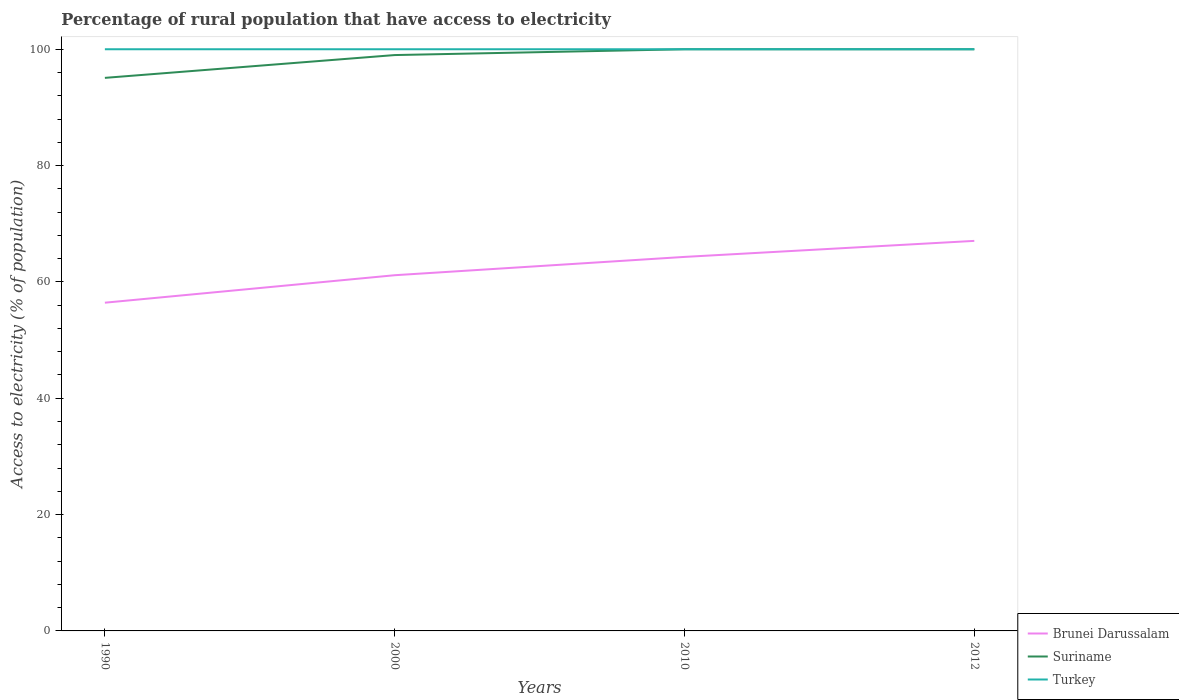Is the number of lines equal to the number of legend labels?
Provide a succinct answer. Yes. Across all years, what is the maximum percentage of rural population that have access to electricity in Turkey?
Ensure brevity in your answer.  100. In which year was the percentage of rural population that have access to electricity in Brunei Darussalam maximum?
Give a very brief answer. 1990. What is the total percentage of rural population that have access to electricity in Brunei Darussalam in the graph?
Your answer should be compact. -3.15. What is the difference between the highest and the second highest percentage of rural population that have access to electricity in Suriname?
Provide a succinct answer. 4.92. What is the difference between the highest and the lowest percentage of rural population that have access to electricity in Brunei Darussalam?
Your answer should be very brief. 2. Are the values on the major ticks of Y-axis written in scientific E-notation?
Keep it short and to the point. No. Where does the legend appear in the graph?
Offer a terse response. Bottom right. How are the legend labels stacked?
Give a very brief answer. Vertical. What is the title of the graph?
Provide a short and direct response. Percentage of rural population that have access to electricity. What is the label or title of the Y-axis?
Offer a very short reply. Access to electricity (% of population). What is the Access to electricity (% of population) in Brunei Darussalam in 1990?
Offer a terse response. 56.43. What is the Access to electricity (% of population) in Suriname in 1990?
Provide a short and direct response. 95.08. What is the Access to electricity (% of population) in Brunei Darussalam in 2000?
Offer a very short reply. 61.15. What is the Access to electricity (% of population) of Brunei Darussalam in 2010?
Provide a succinct answer. 64.3. What is the Access to electricity (% of population) in Turkey in 2010?
Your answer should be very brief. 100. What is the Access to electricity (% of population) in Brunei Darussalam in 2012?
Give a very brief answer. 67.05. What is the Access to electricity (% of population) in Turkey in 2012?
Give a very brief answer. 100. Across all years, what is the maximum Access to electricity (% of population) of Brunei Darussalam?
Ensure brevity in your answer.  67.05. Across all years, what is the maximum Access to electricity (% of population) of Suriname?
Provide a short and direct response. 100. Across all years, what is the maximum Access to electricity (% of population) of Turkey?
Give a very brief answer. 100. Across all years, what is the minimum Access to electricity (% of population) in Brunei Darussalam?
Ensure brevity in your answer.  56.43. Across all years, what is the minimum Access to electricity (% of population) in Suriname?
Ensure brevity in your answer.  95.08. What is the total Access to electricity (% of population) in Brunei Darussalam in the graph?
Your response must be concise. 248.93. What is the total Access to electricity (% of population) in Suriname in the graph?
Your response must be concise. 394.08. What is the total Access to electricity (% of population) in Turkey in the graph?
Make the answer very short. 400. What is the difference between the Access to electricity (% of population) in Brunei Darussalam in 1990 and that in 2000?
Your response must be concise. -4.72. What is the difference between the Access to electricity (% of population) of Suriname in 1990 and that in 2000?
Keep it short and to the point. -3.92. What is the difference between the Access to electricity (% of population) in Brunei Darussalam in 1990 and that in 2010?
Offer a terse response. -7.87. What is the difference between the Access to electricity (% of population) of Suriname in 1990 and that in 2010?
Offer a very short reply. -4.92. What is the difference between the Access to electricity (% of population) in Turkey in 1990 and that in 2010?
Provide a succinct answer. 0. What is the difference between the Access to electricity (% of population) in Brunei Darussalam in 1990 and that in 2012?
Give a very brief answer. -10.63. What is the difference between the Access to electricity (% of population) in Suriname in 1990 and that in 2012?
Offer a terse response. -4.92. What is the difference between the Access to electricity (% of population) in Turkey in 1990 and that in 2012?
Offer a very short reply. 0. What is the difference between the Access to electricity (% of population) of Brunei Darussalam in 2000 and that in 2010?
Provide a succinct answer. -3.15. What is the difference between the Access to electricity (% of population) in Suriname in 2000 and that in 2010?
Make the answer very short. -1. What is the difference between the Access to electricity (% of population) in Turkey in 2000 and that in 2010?
Ensure brevity in your answer.  0. What is the difference between the Access to electricity (% of population) in Brunei Darussalam in 2000 and that in 2012?
Your answer should be very brief. -5.9. What is the difference between the Access to electricity (% of population) of Brunei Darussalam in 2010 and that in 2012?
Provide a succinct answer. -2.75. What is the difference between the Access to electricity (% of population) of Suriname in 2010 and that in 2012?
Your answer should be very brief. 0. What is the difference between the Access to electricity (% of population) in Turkey in 2010 and that in 2012?
Offer a very short reply. 0. What is the difference between the Access to electricity (% of population) of Brunei Darussalam in 1990 and the Access to electricity (% of population) of Suriname in 2000?
Offer a terse response. -42.57. What is the difference between the Access to electricity (% of population) of Brunei Darussalam in 1990 and the Access to electricity (% of population) of Turkey in 2000?
Your answer should be very brief. -43.57. What is the difference between the Access to electricity (% of population) of Suriname in 1990 and the Access to electricity (% of population) of Turkey in 2000?
Offer a terse response. -4.92. What is the difference between the Access to electricity (% of population) in Brunei Darussalam in 1990 and the Access to electricity (% of population) in Suriname in 2010?
Your answer should be compact. -43.57. What is the difference between the Access to electricity (% of population) of Brunei Darussalam in 1990 and the Access to electricity (% of population) of Turkey in 2010?
Offer a terse response. -43.57. What is the difference between the Access to electricity (% of population) in Suriname in 1990 and the Access to electricity (% of population) in Turkey in 2010?
Offer a very short reply. -4.92. What is the difference between the Access to electricity (% of population) in Brunei Darussalam in 1990 and the Access to electricity (% of population) in Suriname in 2012?
Give a very brief answer. -43.57. What is the difference between the Access to electricity (% of population) of Brunei Darussalam in 1990 and the Access to electricity (% of population) of Turkey in 2012?
Your response must be concise. -43.57. What is the difference between the Access to electricity (% of population) of Suriname in 1990 and the Access to electricity (% of population) of Turkey in 2012?
Your answer should be compact. -4.92. What is the difference between the Access to electricity (% of population) of Brunei Darussalam in 2000 and the Access to electricity (% of population) of Suriname in 2010?
Make the answer very short. -38.85. What is the difference between the Access to electricity (% of population) in Brunei Darussalam in 2000 and the Access to electricity (% of population) in Turkey in 2010?
Provide a succinct answer. -38.85. What is the difference between the Access to electricity (% of population) of Brunei Darussalam in 2000 and the Access to electricity (% of population) of Suriname in 2012?
Provide a short and direct response. -38.85. What is the difference between the Access to electricity (% of population) of Brunei Darussalam in 2000 and the Access to electricity (% of population) of Turkey in 2012?
Your answer should be very brief. -38.85. What is the difference between the Access to electricity (% of population) in Brunei Darussalam in 2010 and the Access to electricity (% of population) in Suriname in 2012?
Offer a very short reply. -35.7. What is the difference between the Access to electricity (% of population) in Brunei Darussalam in 2010 and the Access to electricity (% of population) in Turkey in 2012?
Provide a short and direct response. -35.7. What is the average Access to electricity (% of population) of Brunei Darussalam per year?
Provide a short and direct response. 62.23. What is the average Access to electricity (% of population) of Suriname per year?
Keep it short and to the point. 98.52. What is the average Access to electricity (% of population) of Turkey per year?
Provide a short and direct response. 100. In the year 1990, what is the difference between the Access to electricity (% of population) in Brunei Darussalam and Access to electricity (% of population) in Suriname?
Make the answer very short. -38.65. In the year 1990, what is the difference between the Access to electricity (% of population) in Brunei Darussalam and Access to electricity (% of population) in Turkey?
Keep it short and to the point. -43.57. In the year 1990, what is the difference between the Access to electricity (% of population) of Suriname and Access to electricity (% of population) of Turkey?
Your response must be concise. -4.92. In the year 2000, what is the difference between the Access to electricity (% of population) in Brunei Darussalam and Access to electricity (% of population) in Suriname?
Your answer should be very brief. -37.85. In the year 2000, what is the difference between the Access to electricity (% of population) of Brunei Darussalam and Access to electricity (% of population) of Turkey?
Ensure brevity in your answer.  -38.85. In the year 2000, what is the difference between the Access to electricity (% of population) of Suriname and Access to electricity (% of population) of Turkey?
Offer a terse response. -1. In the year 2010, what is the difference between the Access to electricity (% of population) in Brunei Darussalam and Access to electricity (% of population) in Suriname?
Make the answer very short. -35.7. In the year 2010, what is the difference between the Access to electricity (% of population) in Brunei Darussalam and Access to electricity (% of population) in Turkey?
Your response must be concise. -35.7. In the year 2012, what is the difference between the Access to electricity (% of population) of Brunei Darussalam and Access to electricity (% of population) of Suriname?
Give a very brief answer. -32.95. In the year 2012, what is the difference between the Access to electricity (% of population) of Brunei Darussalam and Access to electricity (% of population) of Turkey?
Your response must be concise. -32.95. What is the ratio of the Access to electricity (% of population) of Brunei Darussalam in 1990 to that in 2000?
Give a very brief answer. 0.92. What is the ratio of the Access to electricity (% of population) in Suriname in 1990 to that in 2000?
Your answer should be very brief. 0.96. What is the ratio of the Access to electricity (% of population) of Turkey in 1990 to that in 2000?
Your answer should be compact. 1. What is the ratio of the Access to electricity (% of population) of Brunei Darussalam in 1990 to that in 2010?
Your answer should be very brief. 0.88. What is the ratio of the Access to electricity (% of population) of Suriname in 1990 to that in 2010?
Provide a short and direct response. 0.95. What is the ratio of the Access to electricity (% of population) in Brunei Darussalam in 1990 to that in 2012?
Give a very brief answer. 0.84. What is the ratio of the Access to electricity (% of population) of Suriname in 1990 to that in 2012?
Your response must be concise. 0.95. What is the ratio of the Access to electricity (% of population) of Brunei Darussalam in 2000 to that in 2010?
Offer a terse response. 0.95. What is the ratio of the Access to electricity (% of population) in Turkey in 2000 to that in 2010?
Provide a short and direct response. 1. What is the ratio of the Access to electricity (% of population) of Brunei Darussalam in 2000 to that in 2012?
Your answer should be very brief. 0.91. What is the ratio of the Access to electricity (% of population) of Suriname in 2000 to that in 2012?
Keep it short and to the point. 0.99. What is the ratio of the Access to electricity (% of population) of Turkey in 2000 to that in 2012?
Provide a short and direct response. 1. What is the ratio of the Access to electricity (% of population) of Brunei Darussalam in 2010 to that in 2012?
Make the answer very short. 0.96. What is the difference between the highest and the second highest Access to electricity (% of population) of Brunei Darussalam?
Give a very brief answer. 2.75. What is the difference between the highest and the second highest Access to electricity (% of population) of Turkey?
Your answer should be compact. 0. What is the difference between the highest and the lowest Access to electricity (% of population) in Brunei Darussalam?
Make the answer very short. 10.63. What is the difference between the highest and the lowest Access to electricity (% of population) in Suriname?
Offer a very short reply. 4.92. 